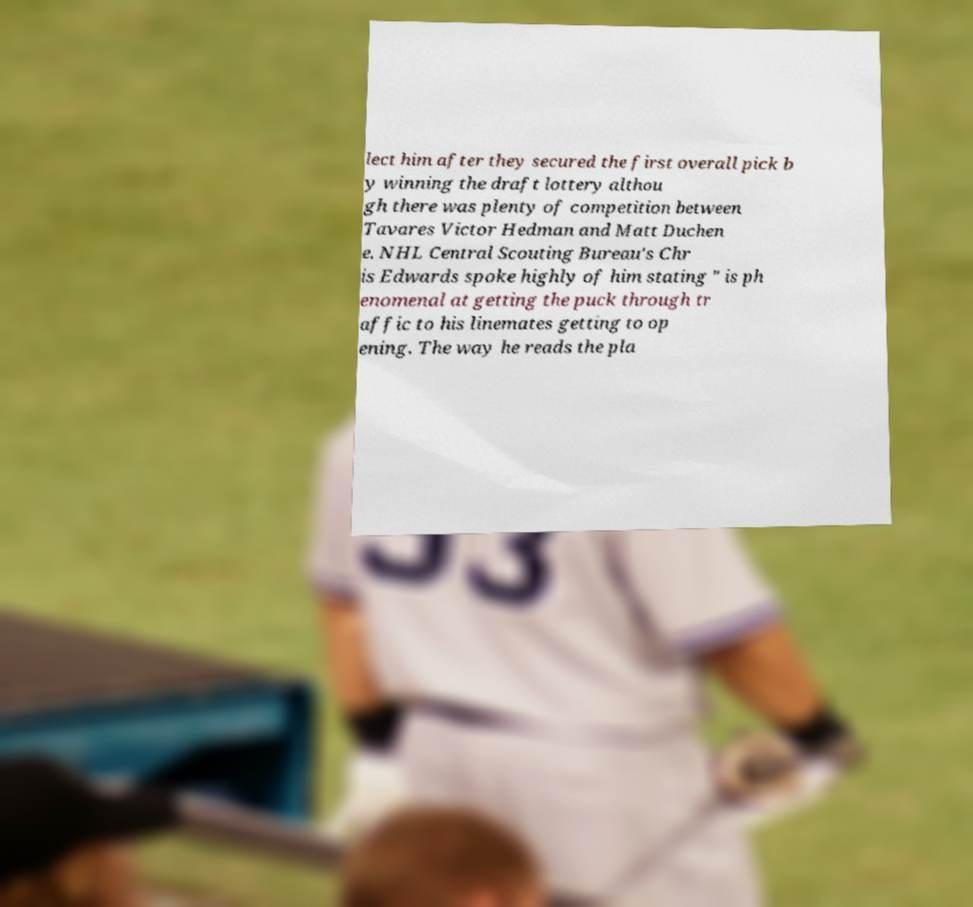Can you read and provide the text displayed in the image?This photo seems to have some interesting text. Can you extract and type it out for me? lect him after they secured the first overall pick b y winning the draft lottery althou gh there was plenty of competition between Tavares Victor Hedman and Matt Duchen e. NHL Central Scouting Bureau's Chr is Edwards spoke highly of him stating " is ph enomenal at getting the puck through tr affic to his linemates getting to op ening. The way he reads the pla 